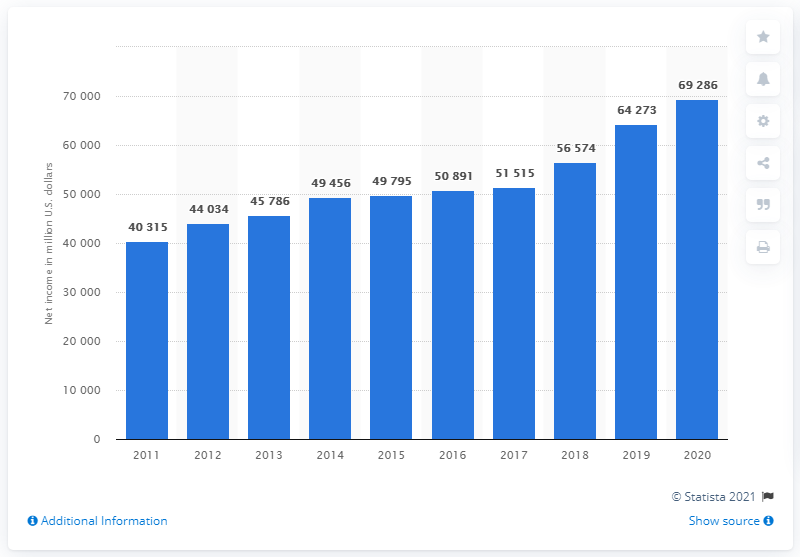Point out several critical features in this image. In the previous year, Southern California Edison's total assets were 64,273. Southern California Edison's total assets in dollars for fiscal year 2020 were 69,286. 